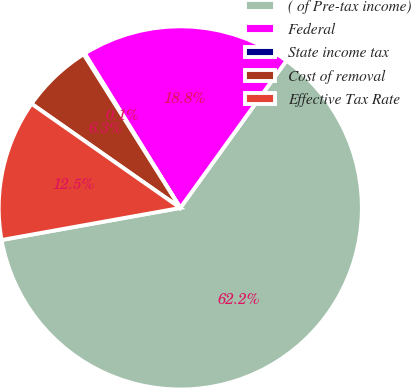Convert chart. <chart><loc_0><loc_0><loc_500><loc_500><pie_chart><fcel>( of Pre-tax income)<fcel>Federal<fcel>State income tax<fcel>Cost of removal<fcel>Effective Tax Rate<nl><fcel>62.24%<fcel>18.76%<fcel>0.12%<fcel>6.34%<fcel>12.55%<nl></chart> 